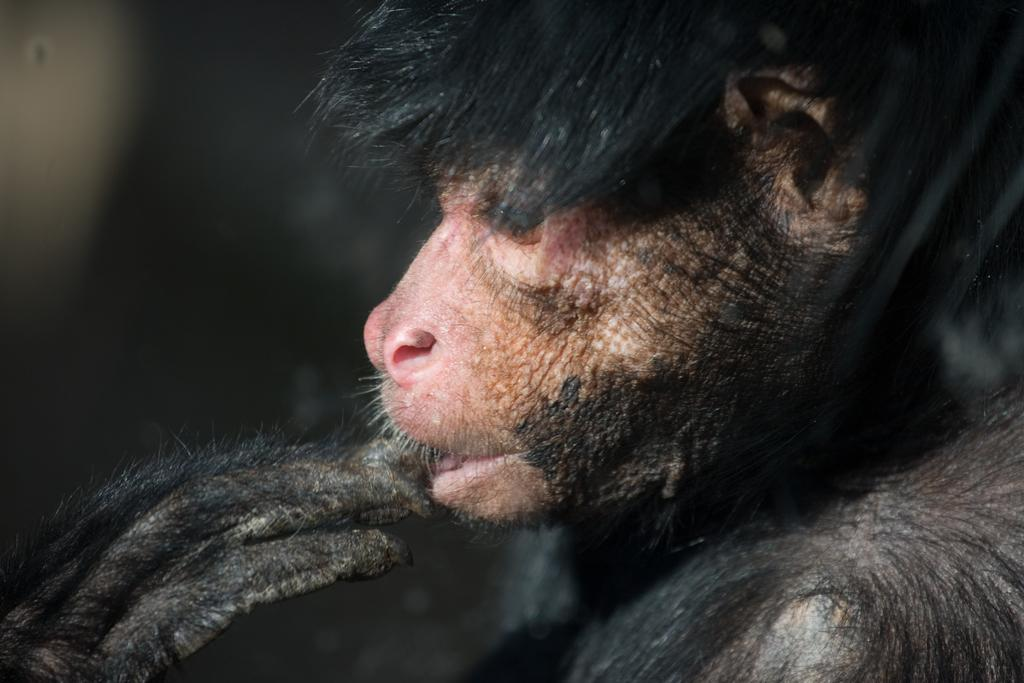What type of living creature is in the image? There is an animal in the image. What can be observed about the background of the image? The background of the image is dark. How many snakes are swimming in the ocean in the image? There is no ocean or snakes present in the image; it features an animal with a dark background. What time of day is depicted in the image? The time of day cannot be determined from the image, as there is no specific indication of time. 